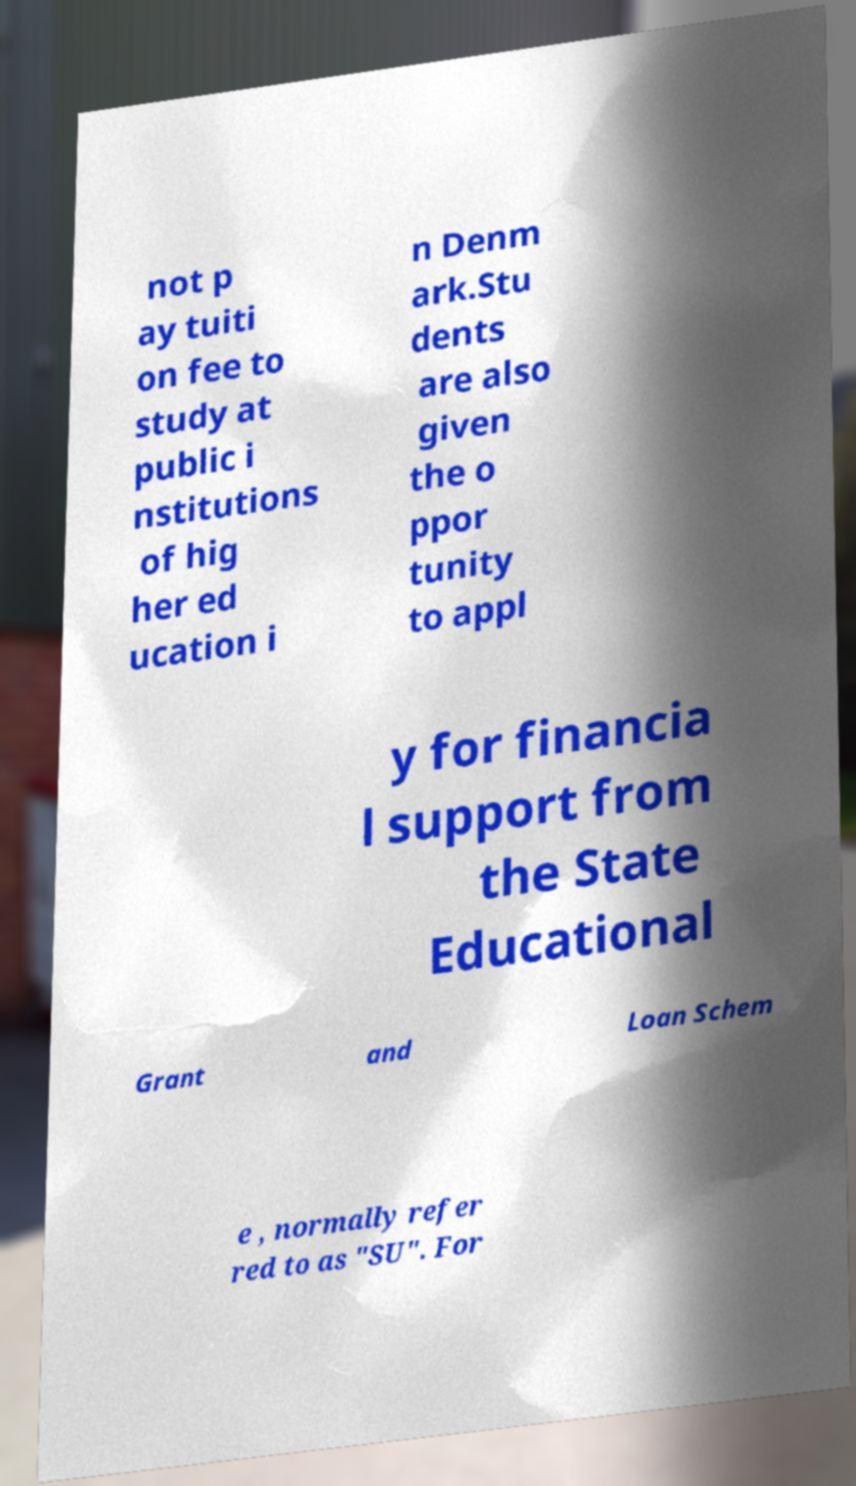I need the written content from this picture converted into text. Can you do that? not p ay tuiti on fee to study at public i nstitutions of hig her ed ucation i n Denm ark.Stu dents are also given the o ppor tunity to appl y for financia l support from the State Educational Grant and Loan Schem e , normally refer red to as "SU". For 